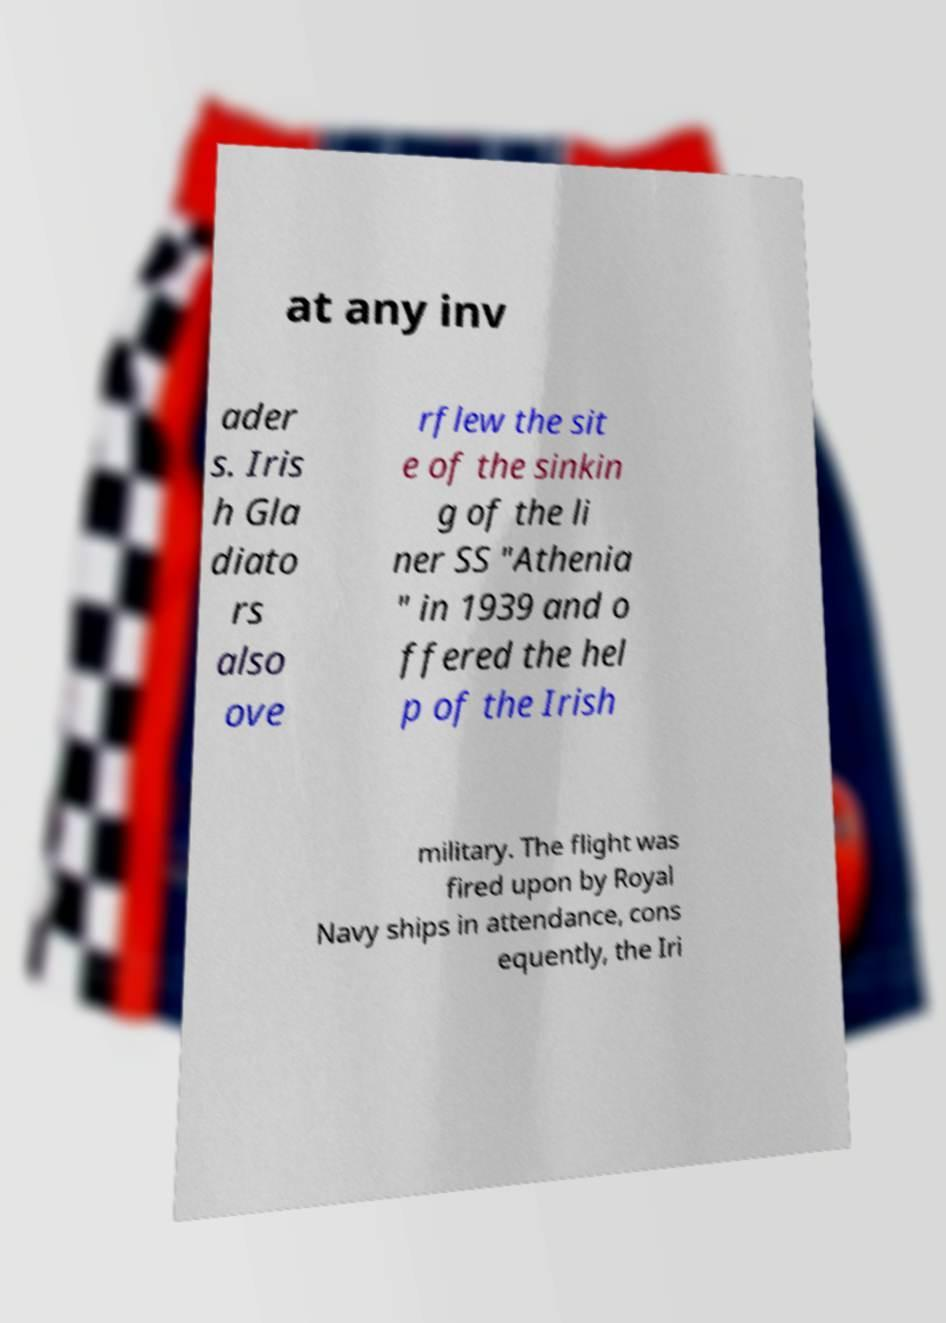Please identify and transcribe the text found in this image. at any inv ader s. Iris h Gla diato rs also ove rflew the sit e of the sinkin g of the li ner SS "Athenia " in 1939 and o ffered the hel p of the Irish military. The flight was fired upon by Royal Navy ships in attendance, cons equently, the Iri 